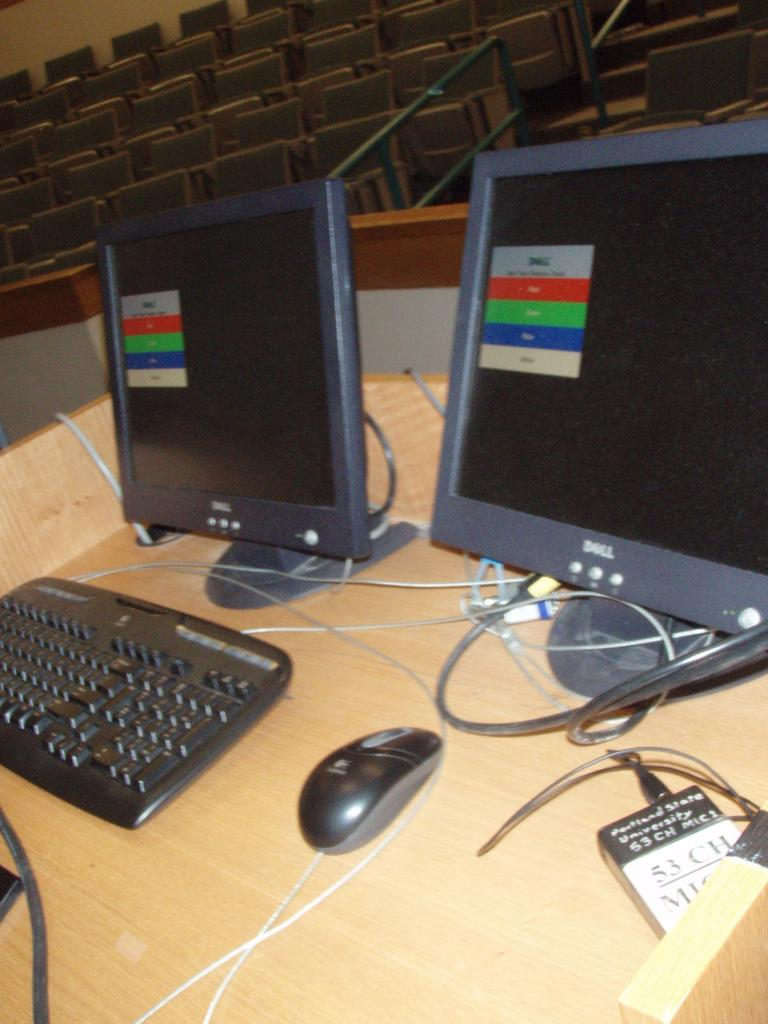Provide a one-sentence caption for the provided image. two monitors sit on the desk of a professor at portland state university. 